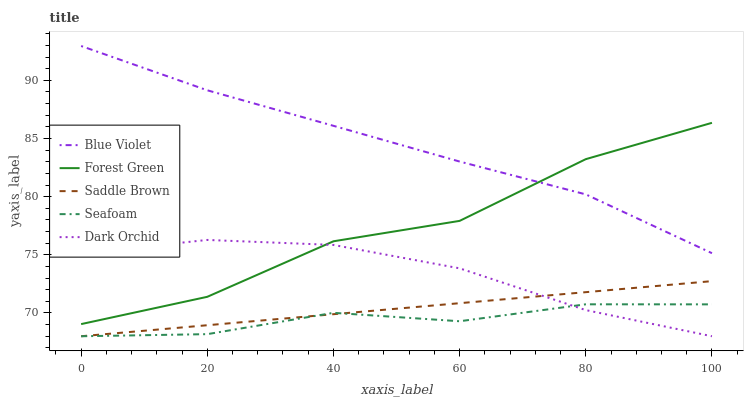Does Seafoam have the minimum area under the curve?
Answer yes or no. Yes. Does Blue Violet have the maximum area under the curve?
Answer yes or no. Yes. Does Forest Green have the minimum area under the curve?
Answer yes or no. No. Does Forest Green have the maximum area under the curve?
Answer yes or no. No. Is Saddle Brown the smoothest?
Answer yes or no. Yes. Is Forest Green the roughest?
Answer yes or no. Yes. Is Forest Green the smoothest?
Answer yes or no. No. Is Saddle Brown the roughest?
Answer yes or no. No. Does Forest Green have the lowest value?
Answer yes or no. No. Does Blue Violet have the highest value?
Answer yes or no. Yes. Does Forest Green have the highest value?
Answer yes or no. No. Is Saddle Brown less than Forest Green?
Answer yes or no. Yes. Is Blue Violet greater than Dark Orchid?
Answer yes or no. Yes. Does Forest Green intersect Dark Orchid?
Answer yes or no. Yes. Is Forest Green less than Dark Orchid?
Answer yes or no. No. Is Forest Green greater than Dark Orchid?
Answer yes or no. No. Does Saddle Brown intersect Forest Green?
Answer yes or no. No. 